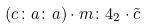<formula> <loc_0><loc_0><loc_500><loc_500>( c \colon a \colon a ) \cdot m \colon 4 _ { 2 } \cdot \tilde { c }</formula> 